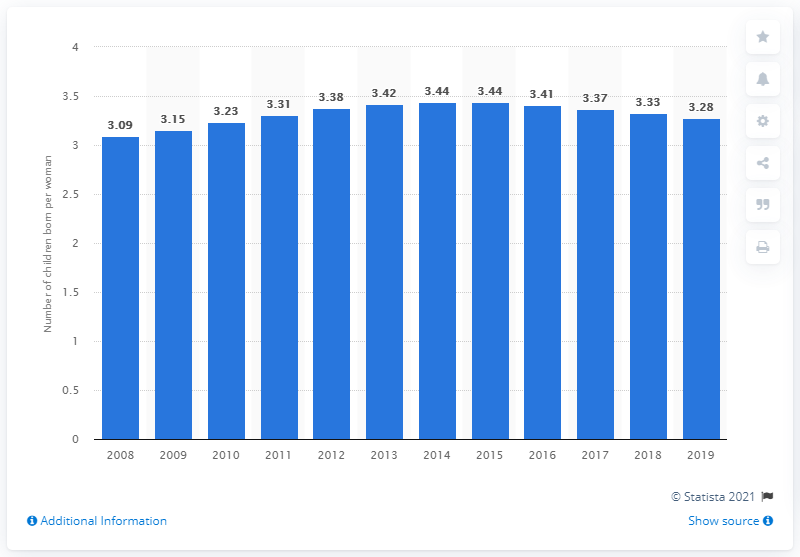Identify some key points in this picture. In 2019, Egypt's fertility rate was 3.28 children per woman. 